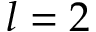Convert formula to latex. <formula><loc_0><loc_0><loc_500><loc_500>l = 2</formula> 